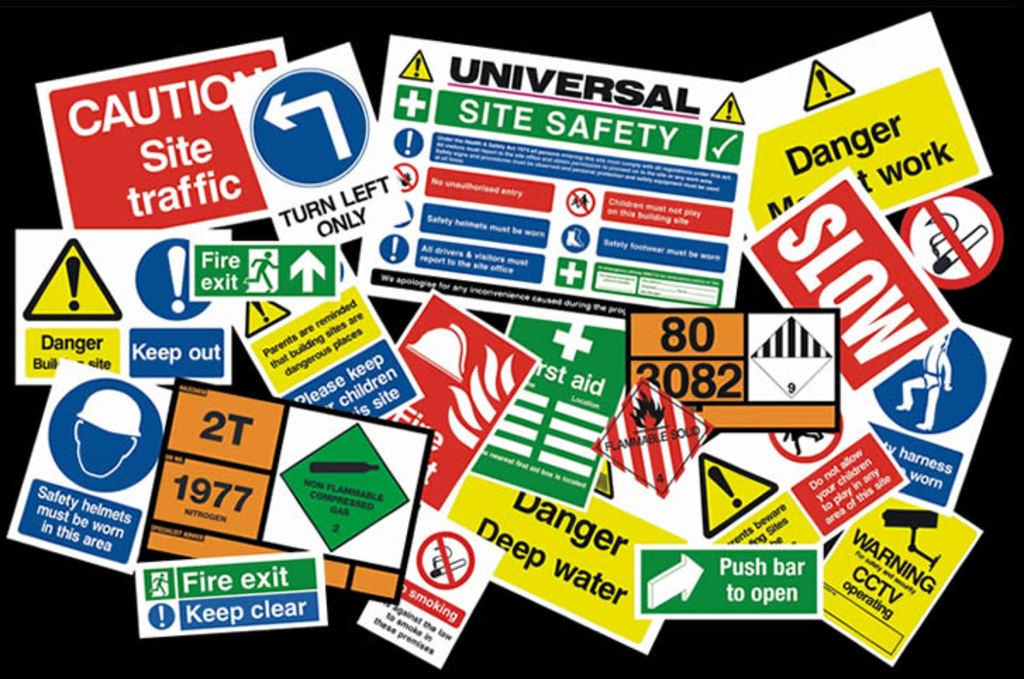What can be seen on the walls in the image? There are posters in the image. How would you describe the overall appearance of the image? The background of the image is dark. What types of elements are featured on the posters? The posters have symbols, text, and numbers present on them. Can you see a maid cleaning the floor in the image? There is no maid or cleaning activity depicted in the image. What type of pipe is visible in the image? There is no pipe present in the image. 